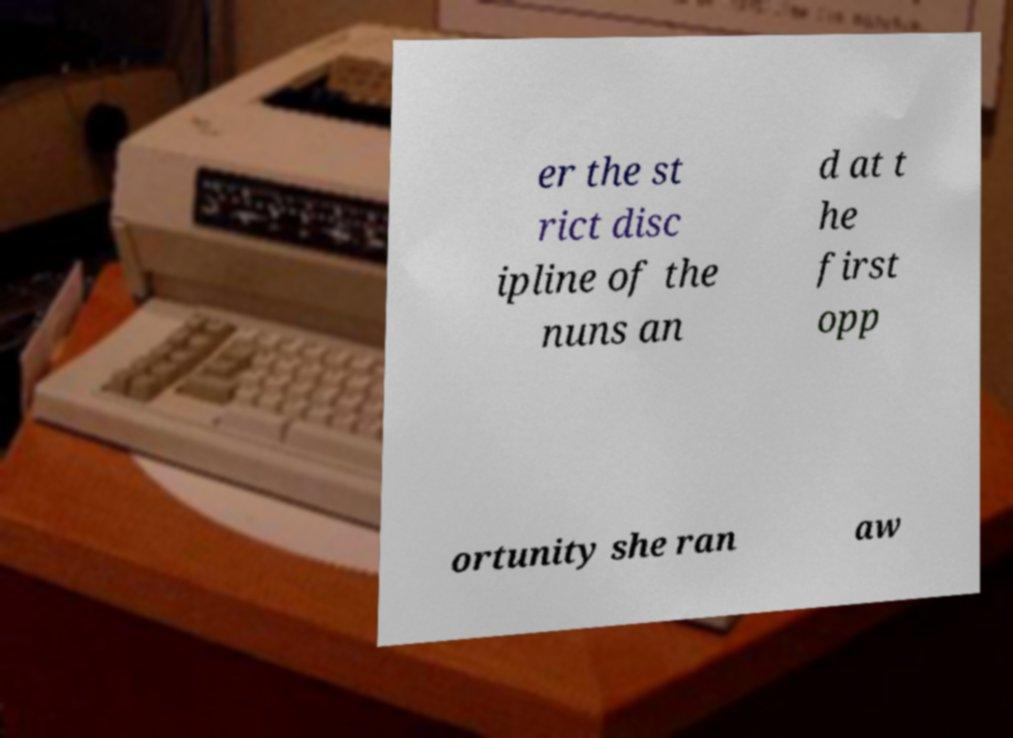Please read and relay the text visible in this image. What does it say? er the st rict disc ipline of the nuns an d at t he first opp ortunity she ran aw 